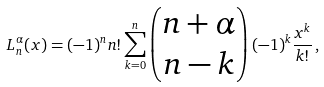<formula> <loc_0><loc_0><loc_500><loc_500>L _ { n } ^ { \alpha } ( x ) = ( - 1 ) ^ { n } n ! \sum _ { k = 0 } ^ { n } \left ( \begin{matrix} n + \alpha \\ n - k \end{matrix} \right ) ( - 1 ) ^ { k } \frac { x ^ { k } } { k ! } \, ,</formula> 